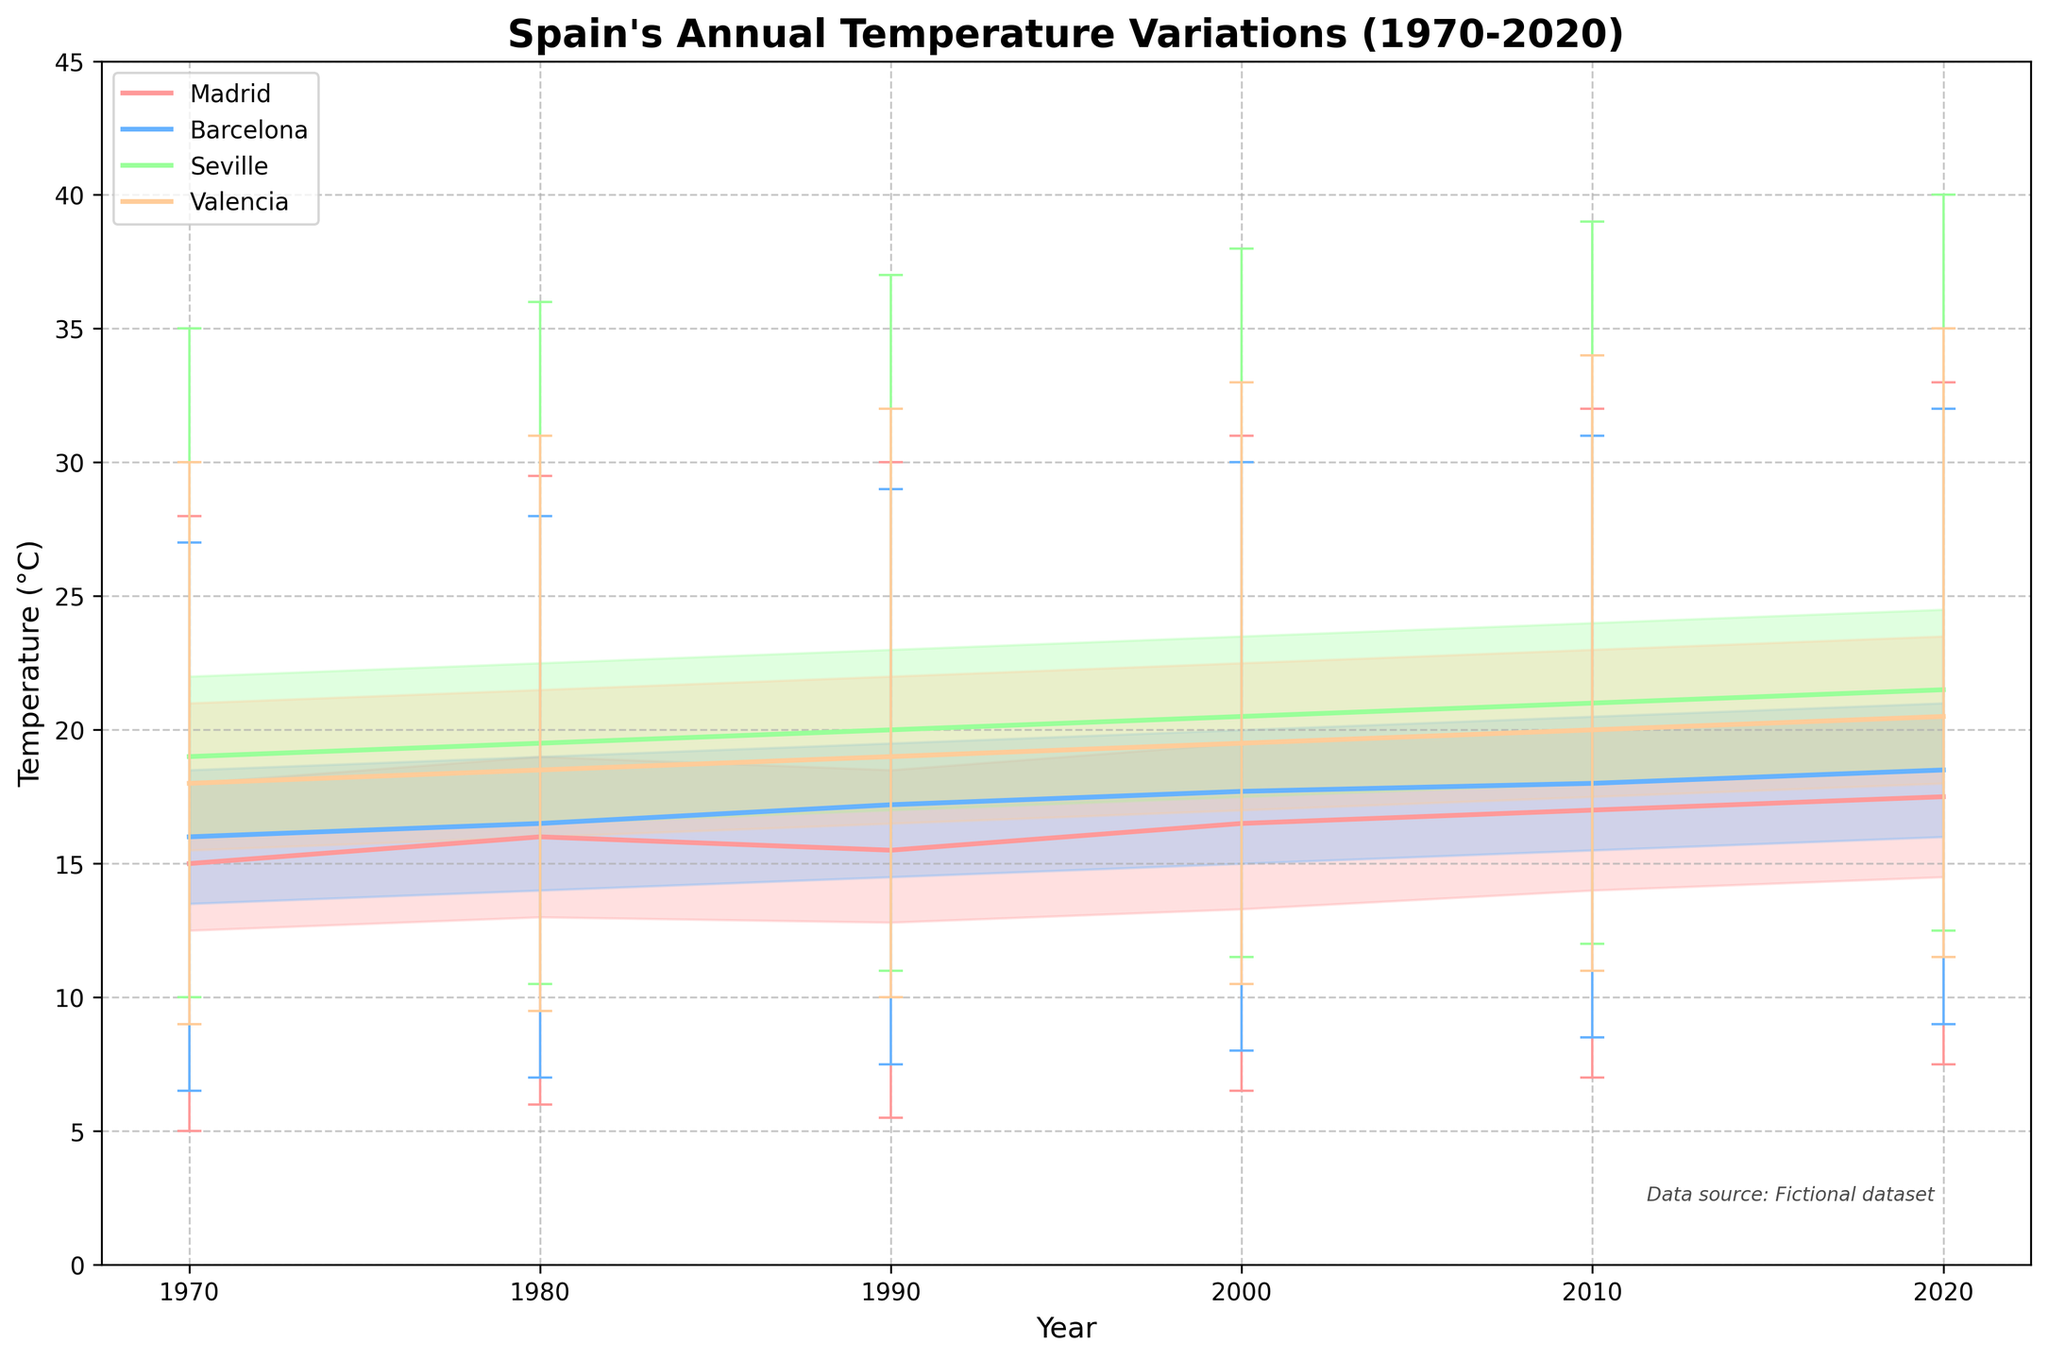How many regions are represented in the plot? Look at the legend in the top left corner of the plot. There are four different colors representing four different regions.
Answer: 4 Which region has the highest maximum temperature in 2020? The highest maximum temperature is marked on the end of the vertical line for each year and region. For 2020, check the endpoints and see Seville reaches 40°C, the highest value among the regions.
Answer: Seville What is the median temperature in Madrid in 1980? Identify the median temperature for Madrid in 1980. Find the corresponding data point in the central line of the candlestick for that year.
Answer: 16.0°C Between which years did Barcelona see an increase in the third quartile temperature? Observe the third quartile values (top edge of the filled area) for each year in the plot for Barcelona. Check from the start in 1970 to the end in 2020 where there is a consistent increase.
Answer: 1970 to 2020 Compare the min temperature of Madrid to Seville in 2010. Which is lower? Locate the min temperature markers (bottom endpoints of the lines) for Madrid and Seville in 2010. Compare the values visually; Madrid’s min temperature is lower.
Answer: Madrid What temperature range does Valencia's third quartile span between 1980 and 2020? Focus on the area between the third quartile values from 1980 to 2020 for Valencia. Identify where the value range increases.
Answer: 16.0°C to 23.5°C Calculate the temperature difference between Valencia's median and Seville's median in 2000. Find and subtract the median temperatures of the two regions for 2000. For Valencia: 19.5°C, for Seville: 20.5°C. The difference is 20.5 - 19.5.
Answer: 1.0°C Identify the year in Seville where the maximum temperature first reached 38.0°C. Locate the highest temperature points (top endpoints of the lines) for Seville and see when it first hits 38.0°C.
Answer: 2000 Explain the trend of Madrid's median temperature from 1970 to 2020. Trace the central line across the years for Madrid and observe its upward slope, indicating a gradual increase in median temperature.
Answer: Increasing Which region shows the smallest increase in minimum temperature from 1970 to 2020? Compare the bottom endpoints of the lines for each region from 1970 to 2020. See which one has the smallest difference. Madrid increases from 5.0°C to 7.5°C, which is the smallest change.
Answer: Madrid 